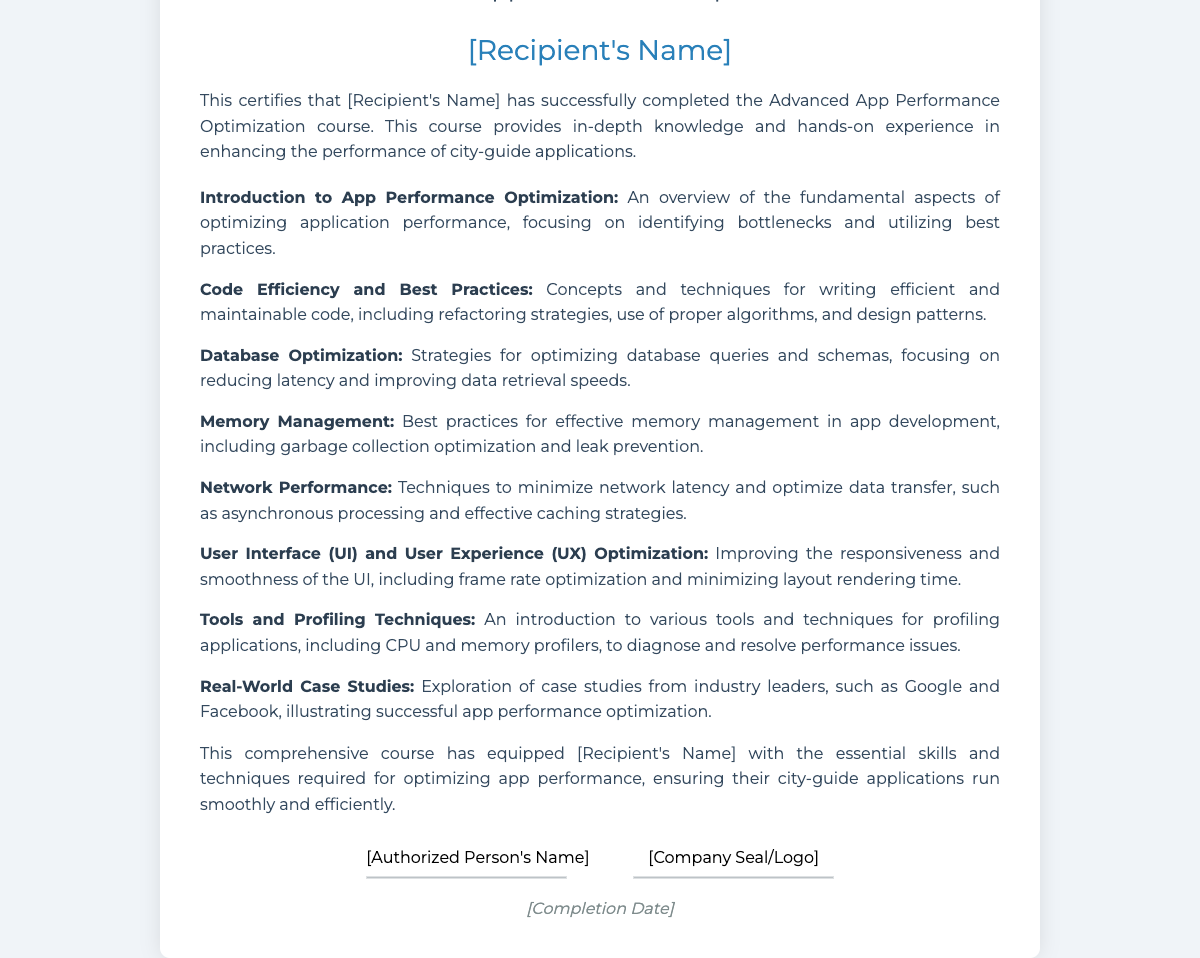what is the title of the course? The title of the course is mentioned at the top of the document as "Advanced App Performance Optimization."
Answer: Advanced App Performance Optimization who is the recipient of the certificate? The recipient's name will be displayed in the document but is currently represented as "[Recipient's Name]."
Answer: [Recipient's Name] how many topics are covered in the course? The document lists a total of eight topics related to app performance optimization.
Answer: 8 what is one topic related to memory management? The document includes "Best practices for effective memory management in app development."
Answer: Memory Management who signs the certificate? The document allows for an authorized person to sign, represented as "[Authorized Person's Name]."
Answer: [Authorized Person's Name] what element can be seen in the footer of the certificate? The footer contains a company seal or logo, indicated as "[Company Seal/Logo]."
Answer: [Company Seal/Logo] what aspect of user interface is discussed in the course? The course discusses "Improving the responsiveness and smoothness of the UI."
Answer: User Interface (UI) and User Experience (UX) Optimization when is the completion date indicated? The completion date is marked in the document as "[Completion Date]."
Answer: [Completion Date] 